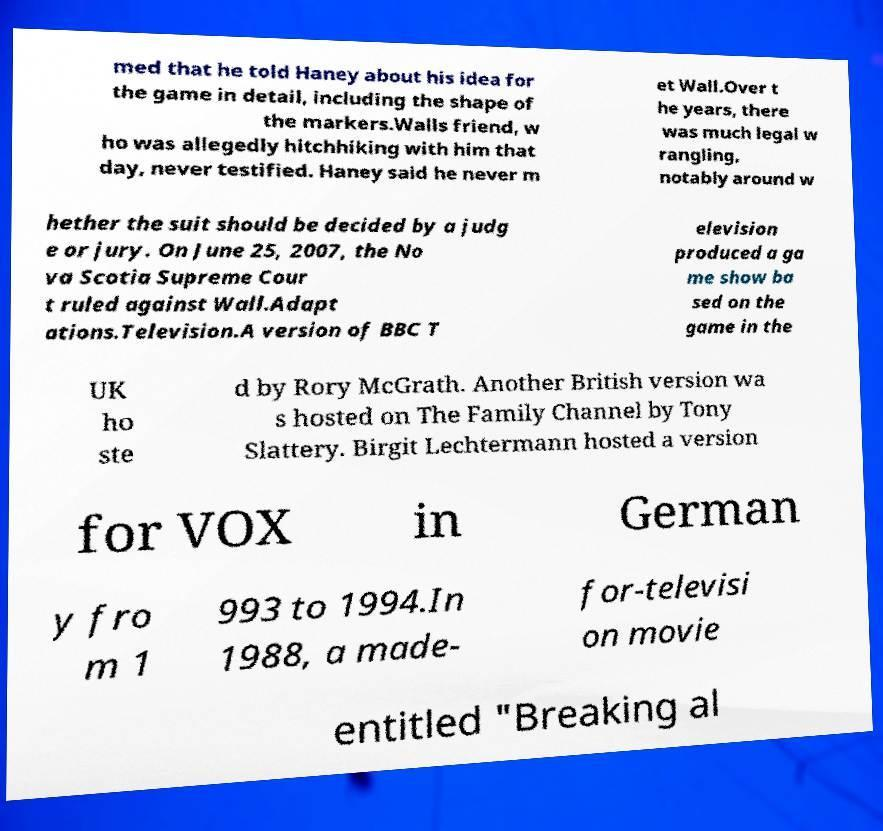What messages or text are displayed in this image? I need them in a readable, typed format. med that he told Haney about his idea for the game in detail, including the shape of the markers.Walls friend, w ho was allegedly hitchhiking with him that day, never testified. Haney said he never m et Wall.Over t he years, there was much legal w rangling, notably around w hether the suit should be decided by a judg e or jury. On June 25, 2007, the No va Scotia Supreme Cour t ruled against Wall.Adapt ations.Television.A version of BBC T elevision produced a ga me show ba sed on the game in the UK ho ste d by Rory McGrath. Another British version wa s hosted on The Family Channel by Tony Slattery. Birgit Lechtermann hosted a version for VOX in German y fro m 1 993 to 1994.In 1988, a made- for-televisi on movie entitled "Breaking al 